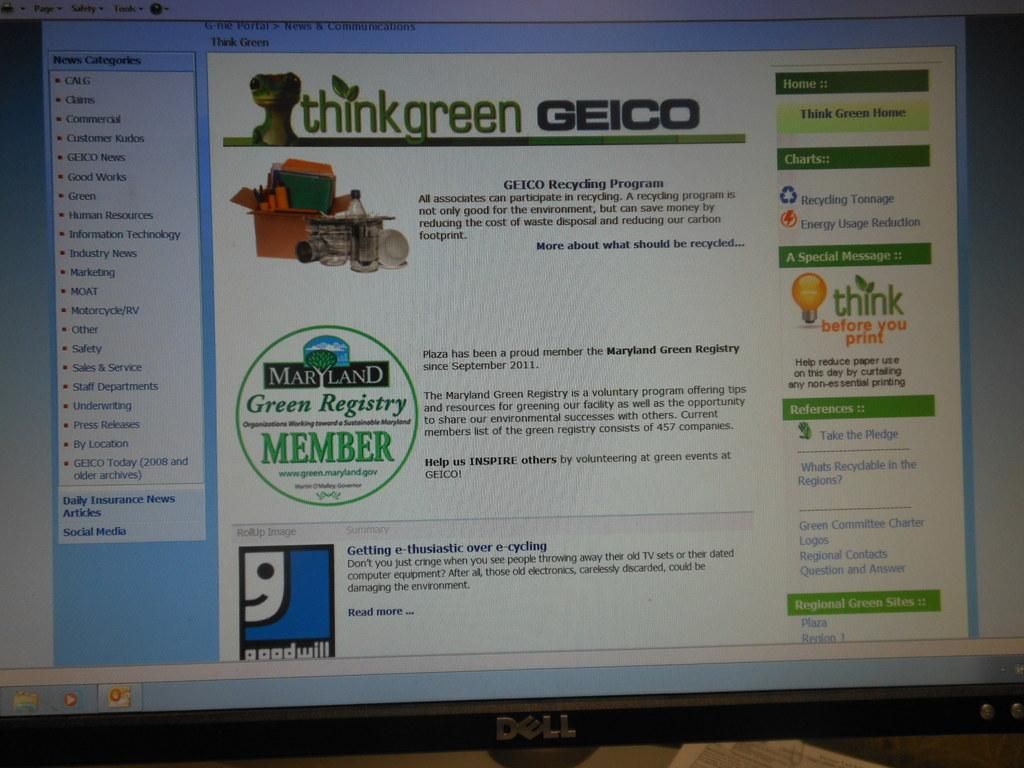Provide a one-sentence caption for the provided image. Dell computer screen with a webpage about geico. 